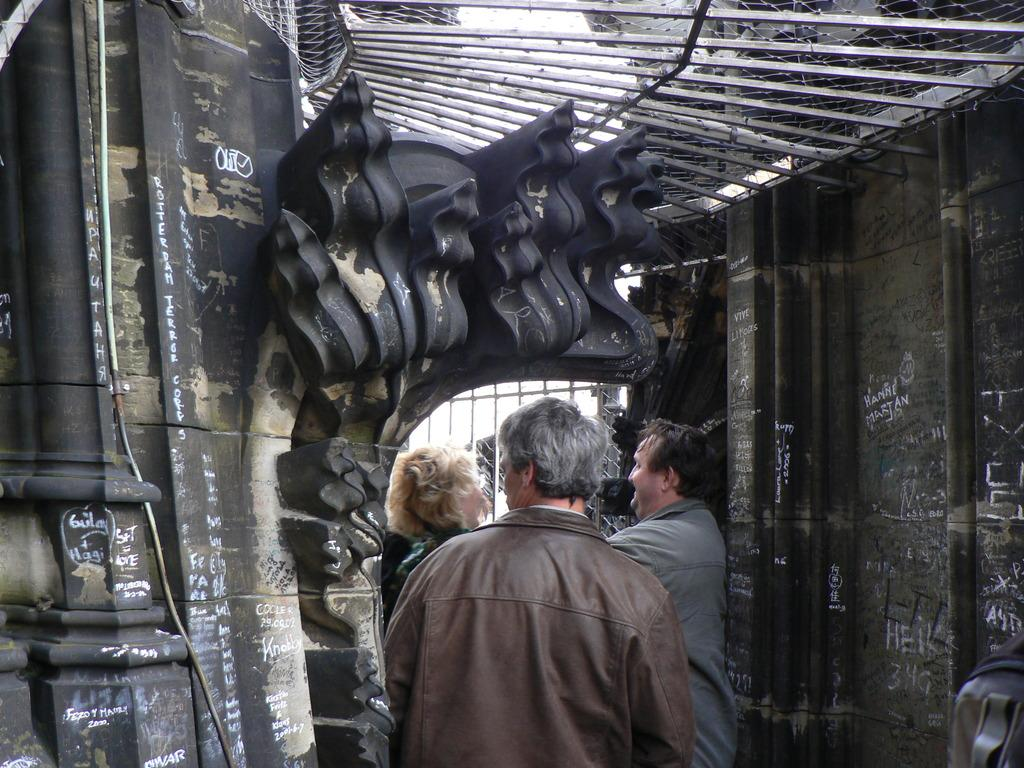How many people are in the image? There is a group of people in the image, but the exact number is not specified. Where are the people located in the image? The people are standing inside a building. What can be seen above the people in the image? There is a roof visible in the image. What material is the roof made of? The roof is made of iron grills. What type of cherry is being shared among the friends in the image? There is no mention of cherries or friends in the image; it only shows a group of people standing inside a building with a roof made of iron grills. 